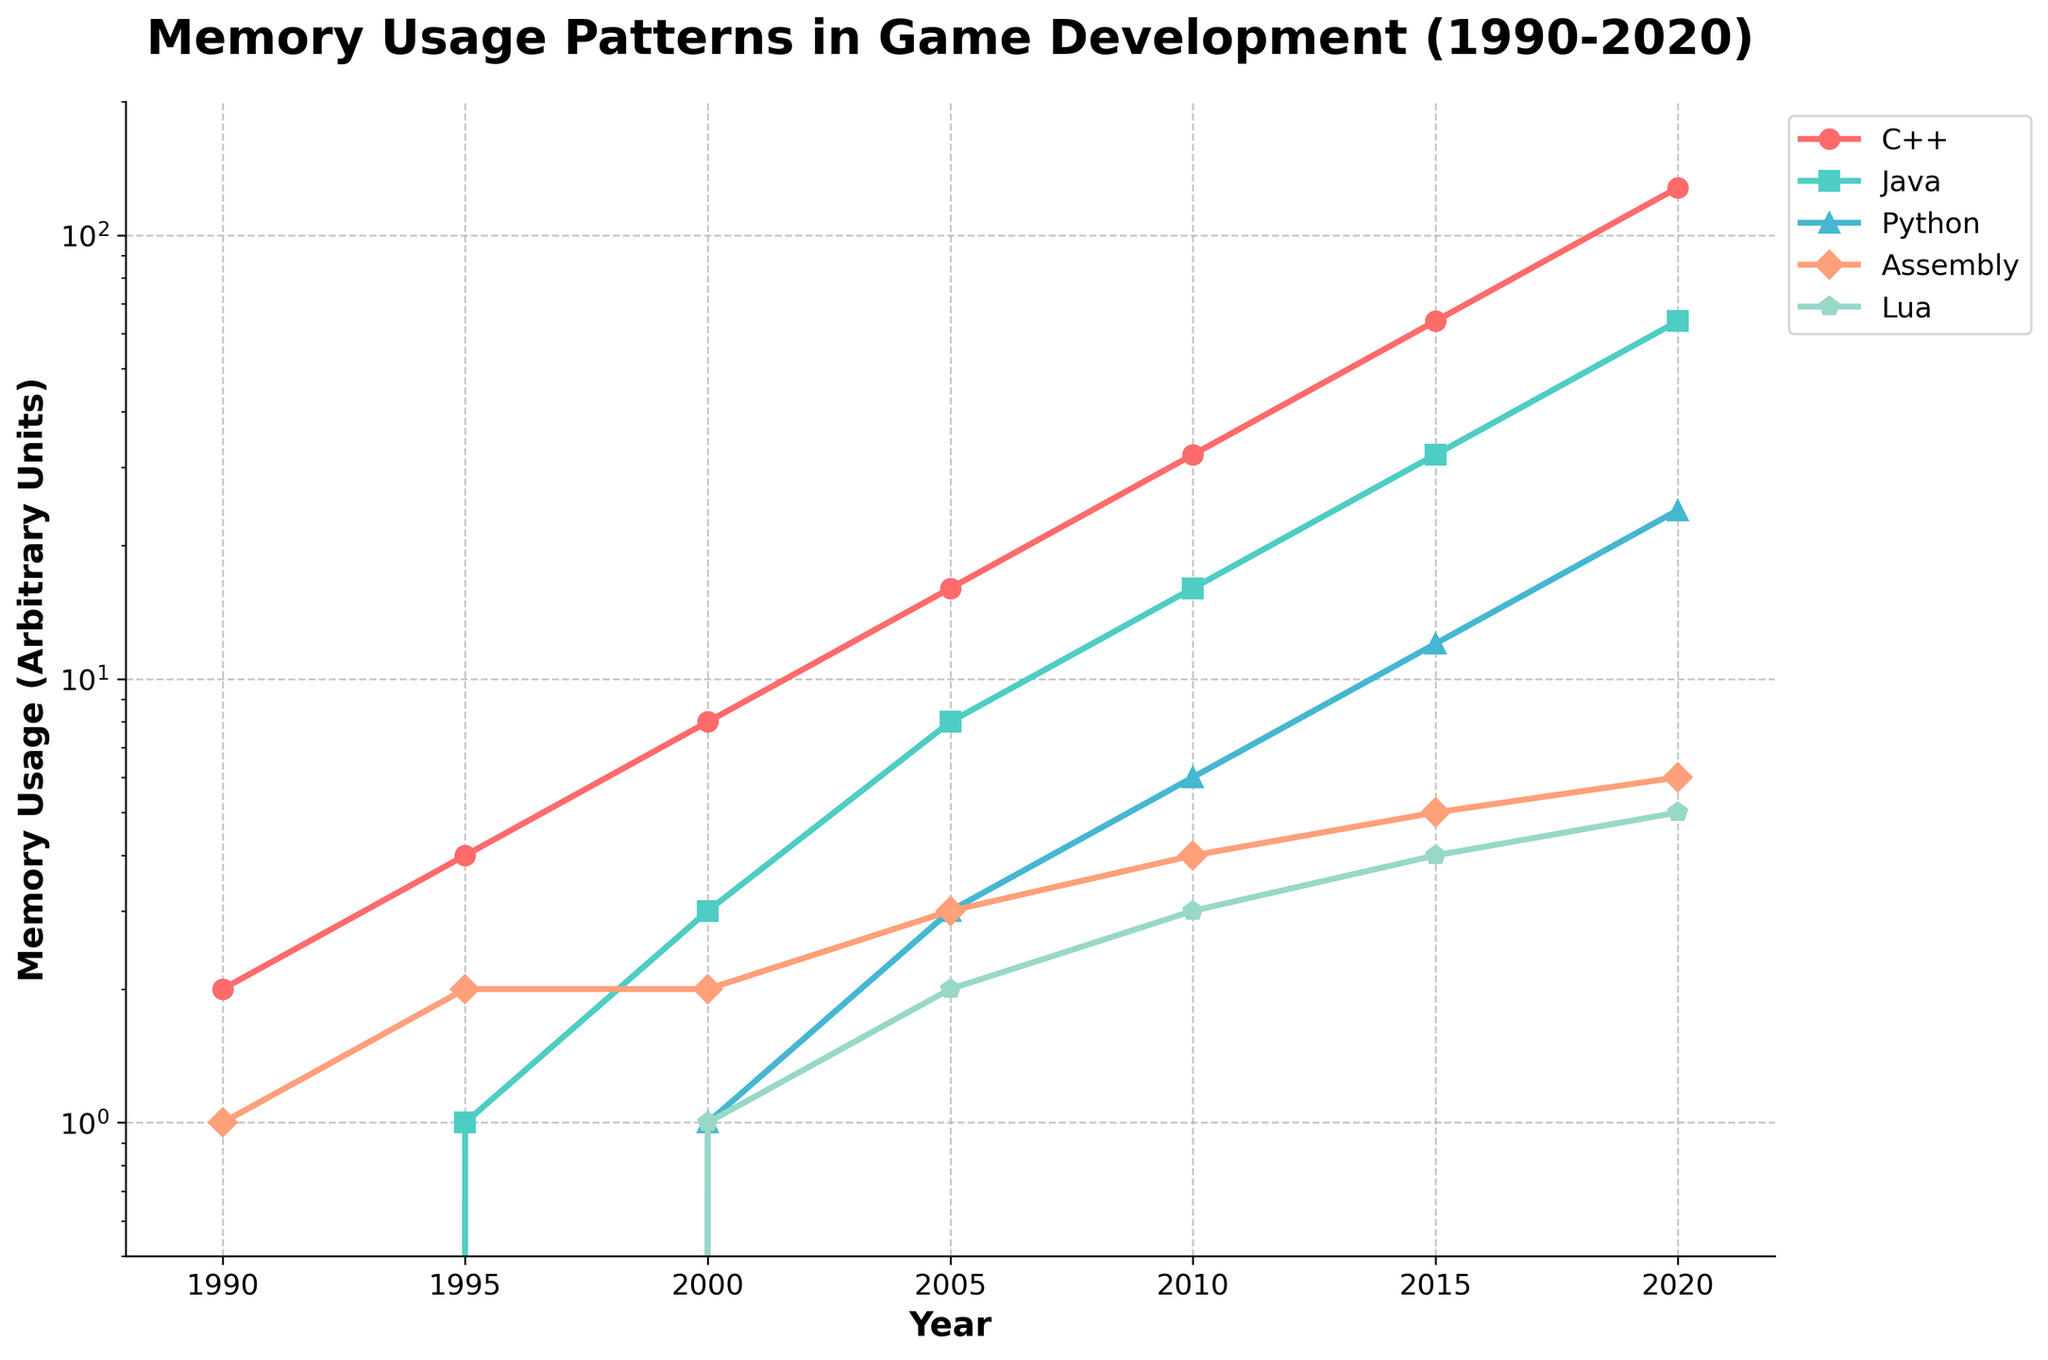What is the general trend of memory usage for all the programming languages from 1990 to 2020? The general trend for all programming languages is an increase in memory usage over the years. Each language, over the period from 1990 to 2020, shows a consistent upward trajectory in memory usage. The scaling is exponential, as indicated by the logarithmic y-axis.
Answer: Increasing Which programming language had the highest memory usage in 2020? Looking at the year 2020, the C++ line is the highest on the chart, indicating it had the highest memory usage among the programming languages listed.
Answer: C++ In which year did Java's memory usage surpass Assembly's usage? To determine when Java's memory usage surpassed Assembly's, look at the intersection point of the Java and Assembly lines. Java's line surpasses Assembly's between 2000 and 2005. So, Java's memory usage surpassed Assembly's in 2005.
Answer: 2005 By how much did Python's memory usage increase from 2000 to 2020? In 2000, Python's memory usage is 1 unit. By 2020, it increased to 24 units. The increase is calculated by subtracting the initial memory usage from the final memory usage: 24 - 1.
Answer: 23 How does Lua's memory usage growth rate from 2000 to 2020 compare with Assembly's in the same period? From 2000 to 2020, Lua's memory usage increased from 1 to 5 units, which is 4 units (5 - 1). Assembly's memory usage increased from 2 to 6 units, which is 4 units (6 - 2). Therefore, both Lua and Assembly's memory usage grew by the same amount over this period.
Answer: Equal What is the ratio of memory usage between C++ and Java in 2010? In 2010, C++'s memory usage is 32 units and Java's is 16 units. The ratio of C++ to Java is calculated as 32 / 16.
Answer: 2:1 Which programming language's memory usage shows the least variation throughout the years? By observing the steepness and consistency of the lines, Assembly shows the least variation in rise compared to others. The line almost uniformly increases with smaller increments.
Answer: Assembly 